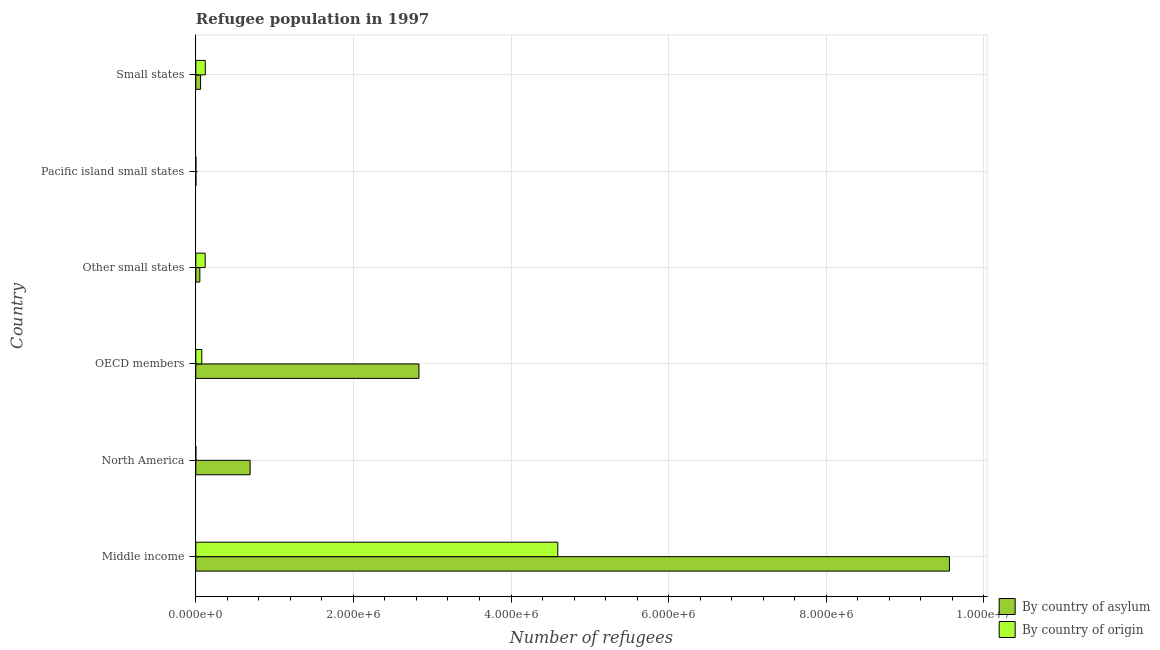How many different coloured bars are there?
Your answer should be compact. 2. Are the number of bars on each tick of the Y-axis equal?
Make the answer very short. Yes. How many bars are there on the 4th tick from the top?
Your answer should be compact. 2. What is the label of the 1st group of bars from the top?
Your answer should be very brief. Small states. What is the number of refugees by country of asylum in Middle income?
Ensure brevity in your answer.  9.56e+06. Across all countries, what is the maximum number of refugees by country of asylum?
Make the answer very short. 9.56e+06. Across all countries, what is the minimum number of refugees by country of asylum?
Offer a terse response. 800. In which country was the number of refugees by country of asylum maximum?
Give a very brief answer. Middle income. In which country was the number of refugees by country of asylum minimum?
Give a very brief answer. Pacific island small states. What is the total number of refugees by country of origin in the graph?
Your response must be concise. 4.91e+06. What is the difference between the number of refugees by country of asylum in North America and that in OECD members?
Provide a short and direct response. -2.14e+06. What is the difference between the number of refugees by country of asylum in Middle income and the number of refugees by country of origin in OECD members?
Ensure brevity in your answer.  9.49e+06. What is the average number of refugees by country of asylum per country?
Keep it short and to the point. 2.20e+06. What is the difference between the number of refugees by country of origin and number of refugees by country of asylum in North America?
Your answer should be compact. -6.89e+05. What is the ratio of the number of refugees by country of asylum in OECD members to that in Pacific island small states?
Offer a terse response. 3539.26. What is the difference between the highest and the second highest number of refugees by country of origin?
Provide a short and direct response. 4.47e+06. What is the difference between the highest and the lowest number of refugees by country of origin?
Offer a terse response. 4.59e+06. In how many countries, is the number of refugees by country of origin greater than the average number of refugees by country of origin taken over all countries?
Provide a succinct answer. 1. What does the 2nd bar from the top in Small states represents?
Offer a very short reply. By country of asylum. What does the 2nd bar from the bottom in OECD members represents?
Your response must be concise. By country of origin. How many bars are there?
Provide a succinct answer. 12. Are all the bars in the graph horizontal?
Give a very brief answer. Yes. How many countries are there in the graph?
Keep it short and to the point. 6. What is the difference between two consecutive major ticks on the X-axis?
Give a very brief answer. 2.00e+06. Does the graph contain any zero values?
Offer a very short reply. No. Where does the legend appear in the graph?
Your answer should be compact. Bottom right. What is the title of the graph?
Offer a terse response. Refugee population in 1997. What is the label or title of the X-axis?
Your answer should be very brief. Number of refugees. What is the Number of refugees of By country of asylum in Middle income?
Your response must be concise. 9.56e+06. What is the Number of refugees in By country of origin in Middle income?
Offer a terse response. 4.59e+06. What is the Number of refugees in By country of asylum in North America?
Give a very brief answer. 6.89e+05. What is the Number of refugees of By country of origin in North America?
Ensure brevity in your answer.  86. What is the Number of refugees in By country of asylum in OECD members?
Your answer should be compact. 2.83e+06. What is the Number of refugees in By country of origin in OECD members?
Provide a short and direct response. 7.59e+04. What is the Number of refugees in By country of asylum in Other small states?
Your response must be concise. 5.11e+04. What is the Number of refugees in By country of origin in Other small states?
Provide a short and direct response. 1.19e+05. What is the Number of refugees in By country of asylum in Pacific island small states?
Give a very brief answer. 800. What is the Number of refugees in By country of origin in Pacific island small states?
Make the answer very short. 367. What is the Number of refugees in By country of asylum in Small states?
Your answer should be very brief. 6.04e+04. What is the Number of refugees in By country of origin in Small states?
Make the answer very short. 1.20e+05. Across all countries, what is the maximum Number of refugees of By country of asylum?
Make the answer very short. 9.56e+06. Across all countries, what is the maximum Number of refugees of By country of origin?
Keep it short and to the point. 4.59e+06. Across all countries, what is the minimum Number of refugees in By country of asylum?
Offer a terse response. 800. What is the total Number of refugees of By country of asylum in the graph?
Ensure brevity in your answer.  1.32e+07. What is the total Number of refugees in By country of origin in the graph?
Your answer should be compact. 4.91e+06. What is the difference between the Number of refugees of By country of asylum in Middle income and that in North America?
Your answer should be very brief. 8.88e+06. What is the difference between the Number of refugees of By country of origin in Middle income and that in North America?
Offer a very short reply. 4.59e+06. What is the difference between the Number of refugees of By country of asylum in Middle income and that in OECD members?
Your response must be concise. 6.73e+06. What is the difference between the Number of refugees in By country of origin in Middle income and that in OECD members?
Your answer should be very brief. 4.52e+06. What is the difference between the Number of refugees in By country of asylum in Middle income and that in Other small states?
Offer a terse response. 9.51e+06. What is the difference between the Number of refugees of By country of origin in Middle income and that in Other small states?
Make the answer very short. 4.48e+06. What is the difference between the Number of refugees in By country of asylum in Middle income and that in Pacific island small states?
Your answer should be very brief. 9.56e+06. What is the difference between the Number of refugees of By country of origin in Middle income and that in Pacific island small states?
Your response must be concise. 4.59e+06. What is the difference between the Number of refugees of By country of asylum in Middle income and that in Small states?
Offer a very short reply. 9.50e+06. What is the difference between the Number of refugees in By country of origin in Middle income and that in Small states?
Your answer should be very brief. 4.47e+06. What is the difference between the Number of refugees of By country of asylum in North America and that in OECD members?
Provide a succinct answer. -2.14e+06. What is the difference between the Number of refugees of By country of origin in North America and that in OECD members?
Offer a terse response. -7.58e+04. What is the difference between the Number of refugees in By country of asylum in North America and that in Other small states?
Your answer should be compact. 6.38e+05. What is the difference between the Number of refugees of By country of origin in North America and that in Other small states?
Your response must be concise. -1.19e+05. What is the difference between the Number of refugees of By country of asylum in North America and that in Pacific island small states?
Offer a very short reply. 6.88e+05. What is the difference between the Number of refugees in By country of origin in North America and that in Pacific island small states?
Your response must be concise. -281. What is the difference between the Number of refugees of By country of asylum in North America and that in Small states?
Offer a very short reply. 6.29e+05. What is the difference between the Number of refugees in By country of origin in North America and that in Small states?
Offer a very short reply. -1.20e+05. What is the difference between the Number of refugees of By country of asylum in OECD members and that in Other small states?
Your response must be concise. 2.78e+06. What is the difference between the Number of refugees of By country of origin in OECD members and that in Other small states?
Ensure brevity in your answer.  -4.29e+04. What is the difference between the Number of refugees of By country of asylum in OECD members and that in Pacific island small states?
Make the answer very short. 2.83e+06. What is the difference between the Number of refugees in By country of origin in OECD members and that in Pacific island small states?
Offer a terse response. 7.55e+04. What is the difference between the Number of refugees in By country of asylum in OECD members and that in Small states?
Your answer should be very brief. 2.77e+06. What is the difference between the Number of refugees of By country of origin in OECD members and that in Small states?
Your answer should be compact. -4.40e+04. What is the difference between the Number of refugees of By country of asylum in Other small states and that in Pacific island small states?
Offer a very short reply. 5.03e+04. What is the difference between the Number of refugees of By country of origin in Other small states and that in Pacific island small states?
Offer a very short reply. 1.18e+05. What is the difference between the Number of refugees in By country of asylum in Other small states and that in Small states?
Provide a succinct answer. -9295. What is the difference between the Number of refugees in By country of origin in Other small states and that in Small states?
Provide a succinct answer. -1143. What is the difference between the Number of refugees of By country of asylum in Pacific island small states and that in Small states?
Make the answer very short. -5.96e+04. What is the difference between the Number of refugees of By country of origin in Pacific island small states and that in Small states?
Ensure brevity in your answer.  -1.20e+05. What is the difference between the Number of refugees of By country of asylum in Middle income and the Number of refugees of By country of origin in North America?
Your response must be concise. 9.56e+06. What is the difference between the Number of refugees of By country of asylum in Middle income and the Number of refugees of By country of origin in OECD members?
Your response must be concise. 9.49e+06. What is the difference between the Number of refugees of By country of asylum in Middle income and the Number of refugees of By country of origin in Other small states?
Offer a terse response. 9.45e+06. What is the difference between the Number of refugees of By country of asylum in Middle income and the Number of refugees of By country of origin in Pacific island small states?
Make the answer very short. 9.56e+06. What is the difference between the Number of refugees of By country of asylum in Middle income and the Number of refugees of By country of origin in Small states?
Provide a succinct answer. 9.44e+06. What is the difference between the Number of refugees in By country of asylum in North America and the Number of refugees in By country of origin in OECD members?
Make the answer very short. 6.13e+05. What is the difference between the Number of refugees of By country of asylum in North America and the Number of refugees of By country of origin in Other small states?
Give a very brief answer. 5.70e+05. What is the difference between the Number of refugees in By country of asylum in North America and the Number of refugees in By country of origin in Pacific island small states?
Your response must be concise. 6.89e+05. What is the difference between the Number of refugees in By country of asylum in North America and the Number of refugees in By country of origin in Small states?
Give a very brief answer. 5.69e+05. What is the difference between the Number of refugees in By country of asylum in OECD members and the Number of refugees in By country of origin in Other small states?
Ensure brevity in your answer.  2.71e+06. What is the difference between the Number of refugees of By country of asylum in OECD members and the Number of refugees of By country of origin in Pacific island small states?
Your answer should be very brief. 2.83e+06. What is the difference between the Number of refugees in By country of asylum in OECD members and the Number of refugees in By country of origin in Small states?
Offer a very short reply. 2.71e+06. What is the difference between the Number of refugees in By country of asylum in Other small states and the Number of refugees in By country of origin in Pacific island small states?
Ensure brevity in your answer.  5.07e+04. What is the difference between the Number of refugees in By country of asylum in Other small states and the Number of refugees in By country of origin in Small states?
Give a very brief answer. -6.88e+04. What is the difference between the Number of refugees of By country of asylum in Pacific island small states and the Number of refugees of By country of origin in Small states?
Your answer should be very brief. -1.19e+05. What is the average Number of refugees in By country of asylum per country?
Keep it short and to the point. 2.20e+06. What is the average Number of refugees of By country of origin per country?
Your answer should be compact. 8.18e+05. What is the difference between the Number of refugees in By country of asylum and Number of refugees in By country of origin in Middle income?
Your answer should be compact. 4.97e+06. What is the difference between the Number of refugees of By country of asylum and Number of refugees of By country of origin in North America?
Provide a succinct answer. 6.89e+05. What is the difference between the Number of refugees in By country of asylum and Number of refugees in By country of origin in OECD members?
Give a very brief answer. 2.76e+06. What is the difference between the Number of refugees in By country of asylum and Number of refugees in By country of origin in Other small states?
Your answer should be compact. -6.77e+04. What is the difference between the Number of refugees in By country of asylum and Number of refugees in By country of origin in Pacific island small states?
Ensure brevity in your answer.  433. What is the difference between the Number of refugees of By country of asylum and Number of refugees of By country of origin in Small states?
Your answer should be compact. -5.95e+04. What is the ratio of the Number of refugees of By country of asylum in Middle income to that in North America?
Keep it short and to the point. 13.88. What is the ratio of the Number of refugees of By country of origin in Middle income to that in North America?
Give a very brief answer. 5.34e+04. What is the ratio of the Number of refugees of By country of asylum in Middle income to that in OECD members?
Your answer should be compact. 3.38. What is the ratio of the Number of refugees in By country of origin in Middle income to that in OECD members?
Offer a terse response. 60.52. What is the ratio of the Number of refugees in By country of asylum in Middle income to that in Other small states?
Your response must be concise. 187.18. What is the ratio of the Number of refugees of By country of origin in Middle income to that in Other small states?
Ensure brevity in your answer.  38.68. What is the ratio of the Number of refugees of By country of asylum in Middle income to that in Pacific island small states?
Provide a short and direct response. 1.20e+04. What is the ratio of the Number of refugees in By country of origin in Middle income to that in Pacific island small states?
Keep it short and to the point. 1.25e+04. What is the ratio of the Number of refugees in By country of asylum in Middle income to that in Small states?
Your response must be concise. 158.37. What is the ratio of the Number of refugees of By country of origin in Middle income to that in Small states?
Offer a very short reply. 38.31. What is the ratio of the Number of refugees in By country of asylum in North America to that in OECD members?
Ensure brevity in your answer.  0.24. What is the ratio of the Number of refugees in By country of origin in North America to that in OECD members?
Give a very brief answer. 0. What is the ratio of the Number of refugees in By country of asylum in North America to that in Other small states?
Give a very brief answer. 13.48. What is the ratio of the Number of refugees in By country of origin in North America to that in Other small states?
Provide a succinct answer. 0. What is the ratio of the Number of refugees in By country of asylum in North America to that in Pacific island small states?
Make the answer very short. 861.28. What is the ratio of the Number of refugees in By country of origin in North America to that in Pacific island small states?
Ensure brevity in your answer.  0.23. What is the ratio of the Number of refugees of By country of asylum in North America to that in Small states?
Make the answer very short. 11.41. What is the ratio of the Number of refugees in By country of origin in North America to that in Small states?
Give a very brief answer. 0. What is the ratio of the Number of refugees in By country of asylum in OECD members to that in Other small states?
Keep it short and to the point. 55.41. What is the ratio of the Number of refugees of By country of origin in OECD members to that in Other small states?
Offer a very short reply. 0.64. What is the ratio of the Number of refugees in By country of asylum in OECD members to that in Pacific island small states?
Offer a terse response. 3539.26. What is the ratio of the Number of refugees in By country of origin in OECD members to that in Pacific island small states?
Provide a short and direct response. 206.81. What is the ratio of the Number of refugees in By country of asylum in OECD members to that in Small states?
Your answer should be very brief. 46.88. What is the ratio of the Number of refugees of By country of origin in OECD members to that in Small states?
Provide a succinct answer. 0.63. What is the ratio of the Number of refugees of By country of asylum in Other small states to that in Pacific island small states?
Your answer should be very brief. 63.87. What is the ratio of the Number of refugees in By country of origin in Other small states to that in Pacific island small states?
Give a very brief answer. 323.6. What is the ratio of the Number of refugees in By country of asylum in Other small states to that in Small states?
Your response must be concise. 0.85. What is the ratio of the Number of refugees of By country of asylum in Pacific island small states to that in Small states?
Ensure brevity in your answer.  0.01. What is the ratio of the Number of refugees of By country of origin in Pacific island small states to that in Small states?
Ensure brevity in your answer.  0. What is the difference between the highest and the second highest Number of refugees of By country of asylum?
Provide a short and direct response. 6.73e+06. What is the difference between the highest and the second highest Number of refugees of By country of origin?
Offer a very short reply. 4.47e+06. What is the difference between the highest and the lowest Number of refugees of By country of asylum?
Your answer should be compact. 9.56e+06. What is the difference between the highest and the lowest Number of refugees of By country of origin?
Your response must be concise. 4.59e+06. 